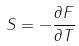Convert formula to latex. <formula><loc_0><loc_0><loc_500><loc_500>S = - \frac { \partial F } { \partial T }</formula> 